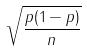Convert formula to latex. <formula><loc_0><loc_0><loc_500><loc_500>\sqrt { \frac { p ( 1 - p ) } { n } }</formula> 